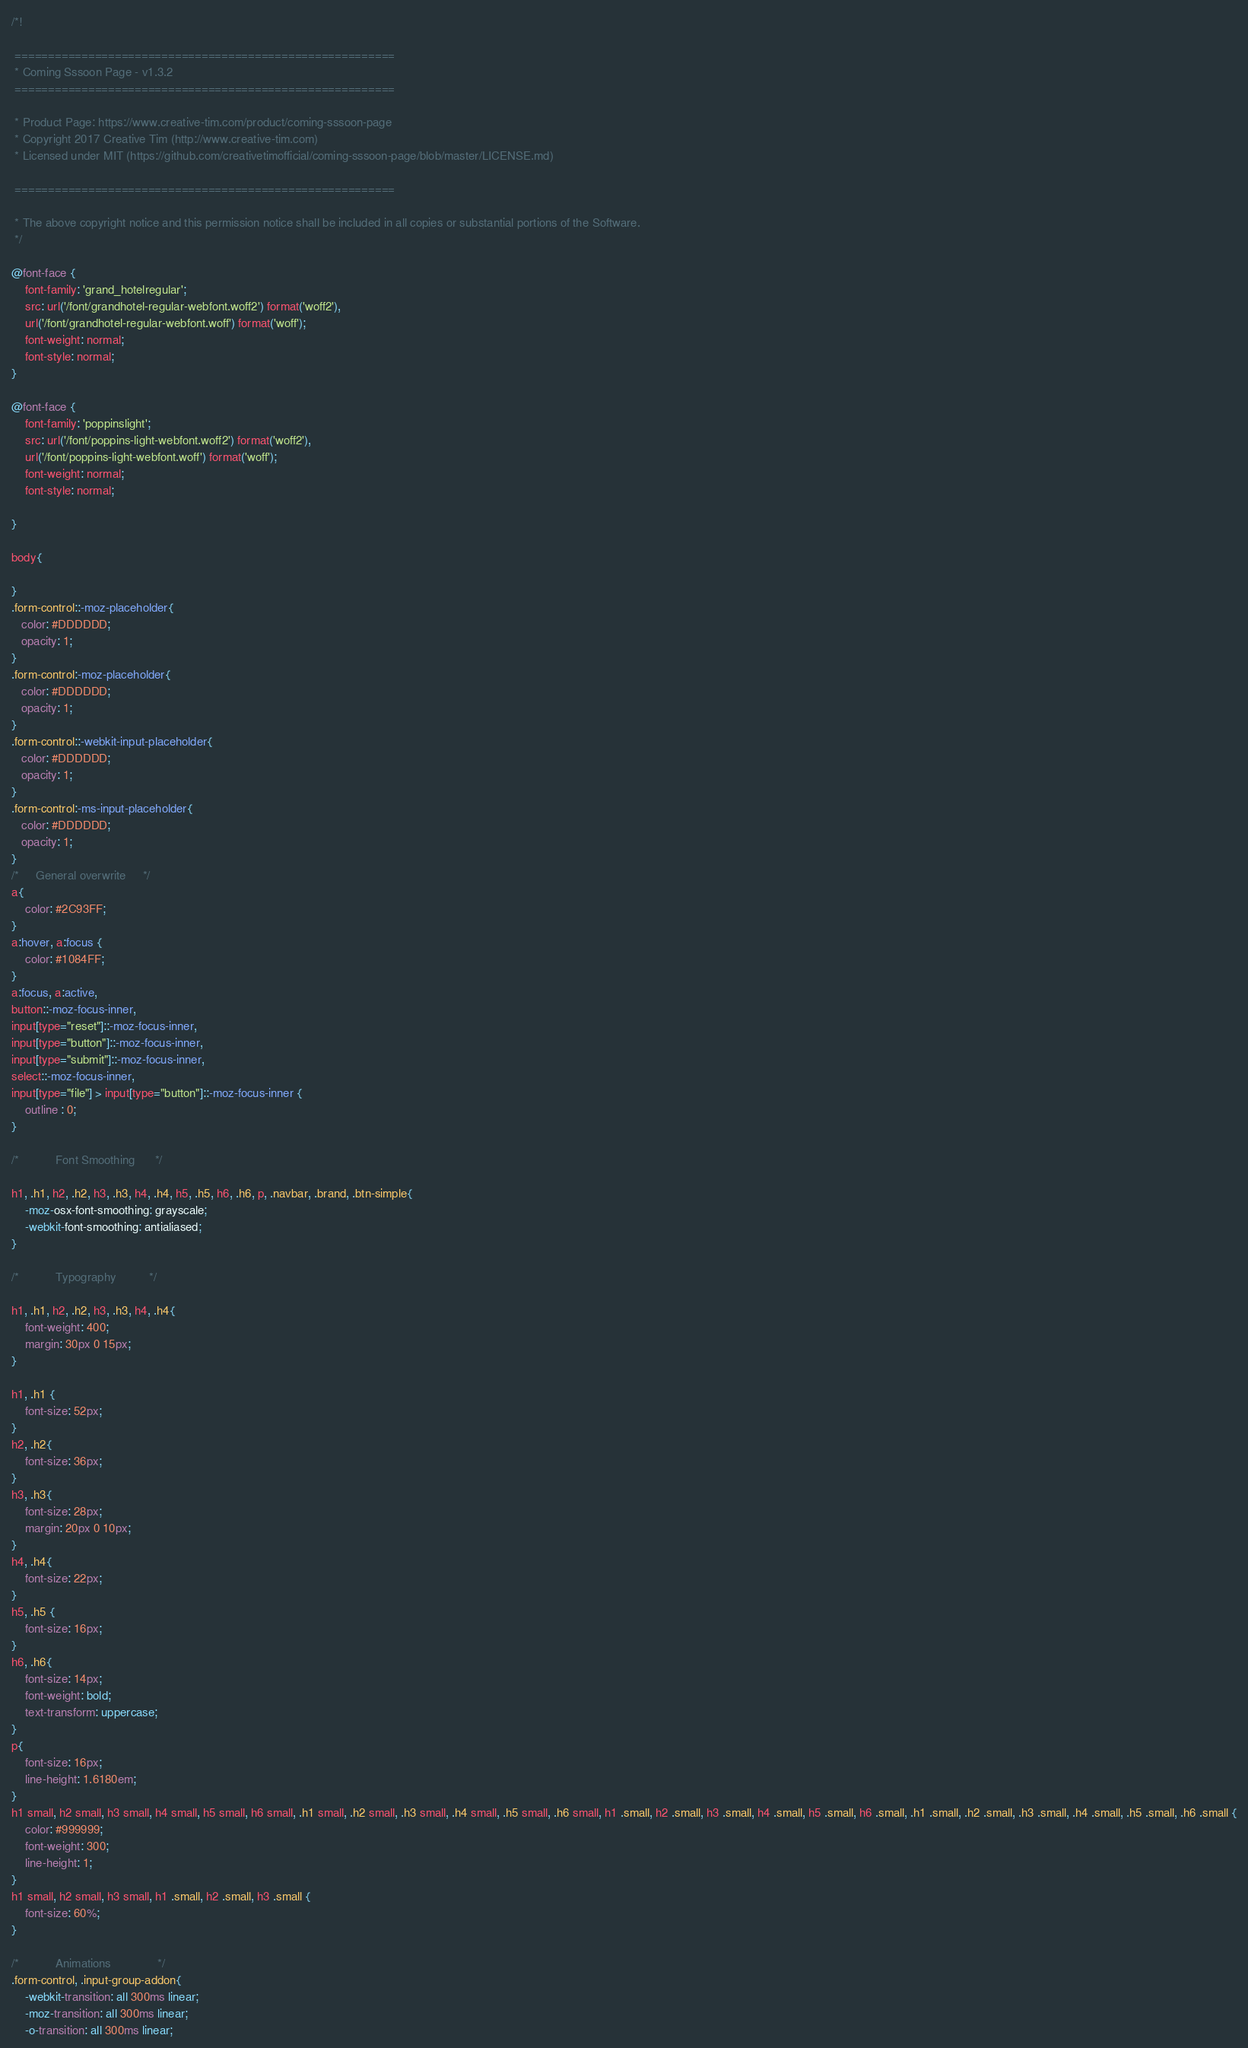<code> <loc_0><loc_0><loc_500><loc_500><_CSS_>/*!

 =========================================================
 * Coming Sssoon Page - v1.3.2
 =========================================================
 
 * Product Page: https://www.creative-tim.com/product/coming-sssoon-page
 * Copyright 2017 Creative Tim (http://www.creative-tim.com)
 * Licensed under MIT (https://github.com/creativetimofficial/coming-sssoon-page/blob/master/LICENSE.md)
 
 =========================================================
 
 * The above copyright notice and this permission notice shall be included in all copies or substantial portions of the Software.
 */

@font-face {
    font-family: 'grand_hotelregular';
    src: url('/font/grandhotel-regular-webfont.woff2') format('woff2'),
    url('/font/grandhotel-regular-webfont.woff') format('woff');
    font-weight: normal;
    font-style: normal;
}

@font-face {
    font-family: 'poppinslight';
    src: url('/font/poppins-light-webfont.woff2') format('woff2'),
    url('/font/poppins-light-webfont.woff') format('woff');
    font-weight: normal;
    font-style: normal;

}

body{
    
}
.form-control::-moz-placeholder{
   color: #DDDDDD;
   opacity: 1;
}
.form-control:-moz-placeholder{
   color: #DDDDDD;
   opacity: 1;  
}  
.form-control::-webkit-input-placeholder{
   color: #DDDDDD;
   opacity: 1; 
} 
.form-control:-ms-input-placeholder{
   color: #DDDDDD;
   opacity: 1; 
}
/*     General overwrite     */
a{
    color: #2C93FF;
}
a:hover, a:focus {
    color: #1084FF;
}
a:focus, a:active, 
button::-moz-focus-inner,
input[type="reset"]::-moz-focus-inner,
input[type="button"]::-moz-focus-inner,
input[type="submit"]::-moz-focus-inner,
select::-moz-focus-inner,
input[type="file"] > input[type="button"]::-moz-focus-inner {
    outline : 0;
}

/*           Font Smoothing      */

h1, .h1, h2, .h2, h3, .h3, h4, .h4, h5, .h5, h6, .h6, p, .navbar, .brand, .btn-simple{
    -moz-osx-font-smoothing: grayscale;
    -webkit-font-smoothing: antialiased;
}

/*           Typography          */

h1, .h1, h2, .h2, h3, .h3, h4, .h4{
    font-weight: 400;
    margin: 30px 0 15px;
}

h1, .h1 {
    font-size: 52px;
}
h2, .h2{
    font-size: 36px;
}
h3, .h3{
    font-size: 28px;
    margin: 20px 0 10px;
}
h4, .h4{
    font-size: 22px;
}
h5, .h5 {
    font-size: 16px;
}
h6, .h6{
    font-size: 14px;
    font-weight: bold;
    text-transform: uppercase;
}
p{
    font-size: 16px;
    line-height: 1.6180em;
}
h1 small, h2 small, h3 small, h4 small, h5 small, h6 small, .h1 small, .h2 small, .h3 small, .h4 small, .h5 small, .h6 small, h1 .small, h2 .small, h3 .small, h4 .small, h5 .small, h6 .small, .h1 .small, .h2 .small, .h3 .small, .h4 .small, .h5 .small, .h6 .small {
    color: #999999;
    font-weight: 300;
    line-height: 1;
}
h1 small, h2 small, h3 small, h1 .small, h2 .small, h3 .small {
    font-size: 60%;
}

/*           Animations              */
.form-control, .input-group-addon{
    -webkit-transition: all 300ms linear;
    -moz-transition: all 300ms linear;
    -o-transition: all 300ms linear;</code> 